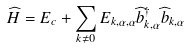Convert formula to latex. <formula><loc_0><loc_0><loc_500><loc_500>\widehat { H } = E _ { c } + \sum _ { k \neq 0 } E _ { k , \alpha , \alpha } \widehat { b } _ { k , \alpha } ^ { \dagger } \widehat { b } _ { k , \alpha }</formula> 